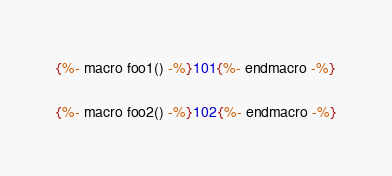<code> <loc_0><loc_0><loc_500><loc_500><_SQL_>{%- macro foo1() -%}101{%- endmacro -%}

{%- macro foo2() -%}102{%- endmacro -%}
</code> 